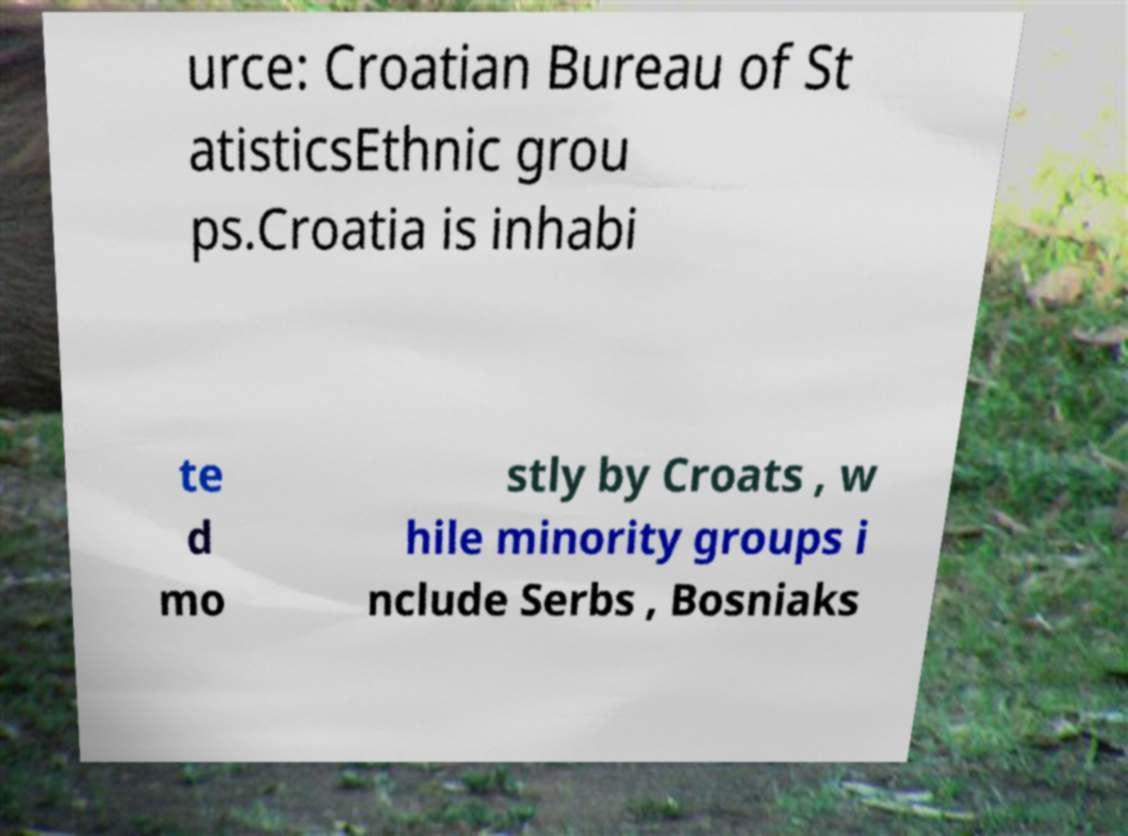Can you accurately transcribe the text from the provided image for me? urce: Croatian Bureau of St atisticsEthnic grou ps.Croatia is inhabi te d mo stly by Croats , w hile minority groups i nclude Serbs , Bosniaks 